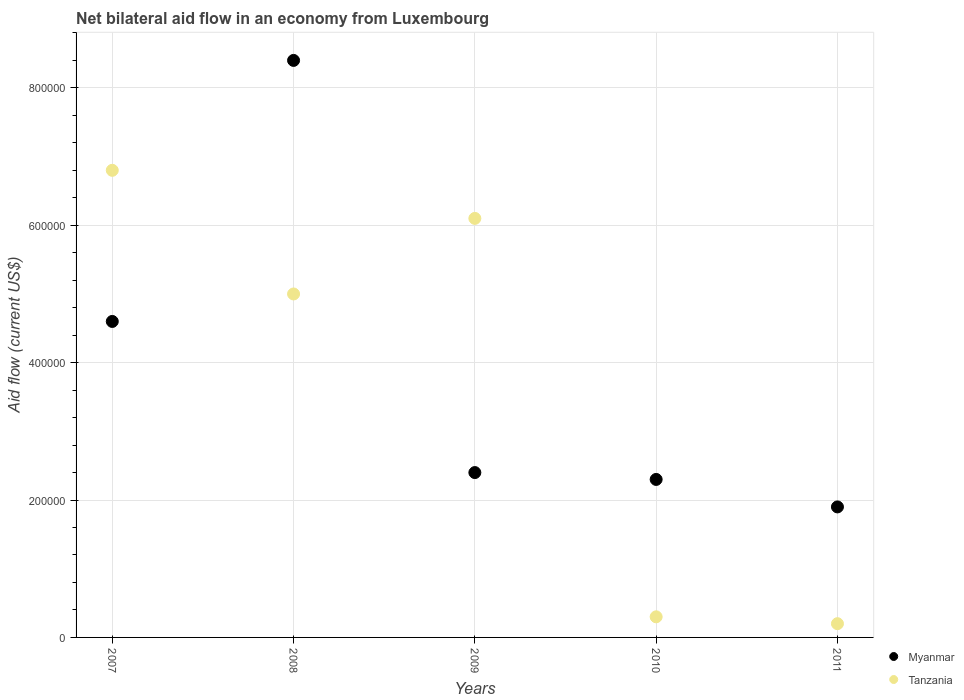How many different coloured dotlines are there?
Your answer should be very brief. 2. Is the number of dotlines equal to the number of legend labels?
Offer a very short reply. Yes. Across all years, what is the maximum net bilateral aid flow in Tanzania?
Keep it short and to the point. 6.80e+05. In which year was the net bilateral aid flow in Tanzania minimum?
Offer a very short reply. 2011. What is the total net bilateral aid flow in Tanzania in the graph?
Provide a succinct answer. 1.84e+06. What is the difference between the net bilateral aid flow in Tanzania in 2009 and that in 2010?
Ensure brevity in your answer.  5.80e+05. What is the difference between the net bilateral aid flow in Myanmar in 2007 and the net bilateral aid flow in Tanzania in 2009?
Your answer should be very brief. -1.50e+05. What is the average net bilateral aid flow in Myanmar per year?
Offer a terse response. 3.92e+05. In the year 2009, what is the difference between the net bilateral aid flow in Myanmar and net bilateral aid flow in Tanzania?
Make the answer very short. -3.70e+05. What is the ratio of the net bilateral aid flow in Myanmar in 2009 to that in 2011?
Your answer should be very brief. 1.26. Is the difference between the net bilateral aid flow in Myanmar in 2010 and 2011 greater than the difference between the net bilateral aid flow in Tanzania in 2010 and 2011?
Offer a very short reply. Yes. In how many years, is the net bilateral aid flow in Tanzania greater than the average net bilateral aid flow in Tanzania taken over all years?
Your response must be concise. 3. Is the sum of the net bilateral aid flow in Myanmar in 2008 and 2011 greater than the maximum net bilateral aid flow in Tanzania across all years?
Your answer should be compact. Yes. Is the net bilateral aid flow in Tanzania strictly less than the net bilateral aid flow in Myanmar over the years?
Offer a very short reply. No. How many years are there in the graph?
Give a very brief answer. 5. What is the difference between two consecutive major ticks on the Y-axis?
Provide a succinct answer. 2.00e+05. How are the legend labels stacked?
Your answer should be very brief. Vertical. What is the title of the graph?
Your response must be concise. Net bilateral aid flow in an economy from Luxembourg. Does "Macedonia" appear as one of the legend labels in the graph?
Your answer should be very brief. No. What is the label or title of the X-axis?
Ensure brevity in your answer.  Years. What is the label or title of the Y-axis?
Your answer should be very brief. Aid flow (current US$). What is the Aid flow (current US$) in Tanzania in 2007?
Your answer should be very brief. 6.80e+05. What is the Aid flow (current US$) of Myanmar in 2008?
Keep it short and to the point. 8.40e+05. What is the Aid flow (current US$) of Tanzania in 2008?
Your answer should be very brief. 5.00e+05. What is the Aid flow (current US$) in Tanzania in 2009?
Your answer should be compact. 6.10e+05. Across all years, what is the maximum Aid flow (current US$) in Myanmar?
Provide a succinct answer. 8.40e+05. Across all years, what is the maximum Aid flow (current US$) in Tanzania?
Ensure brevity in your answer.  6.80e+05. Across all years, what is the minimum Aid flow (current US$) of Myanmar?
Offer a terse response. 1.90e+05. What is the total Aid flow (current US$) in Myanmar in the graph?
Provide a succinct answer. 1.96e+06. What is the total Aid flow (current US$) of Tanzania in the graph?
Provide a short and direct response. 1.84e+06. What is the difference between the Aid flow (current US$) of Myanmar in 2007 and that in 2008?
Your response must be concise. -3.80e+05. What is the difference between the Aid flow (current US$) in Tanzania in 2007 and that in 2010?
Your answer should be very brief. 6.50e+05. What is the difference between the Aid flow (current US$) in Tanzania in 2007 and that in 2011?
Keep it short and to the point. 6.60e+05. What is the difference between the Aid flow (current US$) of Myanmar in 2008 and that in 2009?
Give a very brief answer. 6.00e+05. What is the difference between the Aid flow (current US$) in Myanmar in 2008 and that in 2011?
Offer a terse response. 6.50e+05. What is the difference between the Aid flow (current US$) of Tanzania in 2009 and that in 2010?
Offer a terse response. 5.80e+05. What is the difference between the Aid flow (current US$) of Myanmar in 2009 and that in 2011?
Keep it short and to the point. 5.00e+04. What is the difference between the Aid flow (current US$) of Tanzania in 2009 and that in 2011?
Offer a terse response. 5.90e+05. What is the difference between the Aid flow (current US$) of Tanzania in 2010 and that in 2011?
Your answer should be compact. 10000. What is the difference between the Aid flow (current US$) of Myanmar in 2007 and the Aid flow (current US$) of Tanzania in 2008?
Offer a terse response. -4.00e+04. What is the difference between the Aid flow (current US$) of Myanmar in 2007 and the Aid flow (current US$) of Tanzania in 2011?
Give a very brief answer. 4.40e+05. What is the difference between the Aid flow (current US$) of Myanmar in 2008 and the Aid flow (current US$) of Tanzania in 2009?
Your answer should be compact. 2.30e+05. What is the difference between the Aid flow (current US$) in Myanmar in 2008 and the Aid flow (current US$) in Tanzania in 2010?
Give a very brief answer. 8.10e+05. What is the difference between the Aid flow (current US$) of Myanmar in 2008 and the Aid flow (current US$) of Tanzania in 2011?
Provide a short and direct response. 8.20e+05. What is the difference between the Aid flow (current US$) of Myanmar in 2009 and the Aid flow (current US$) of Tanzania in 2011?
Your answer should be compact. 2.20e+05. What is the difference between the Aid flow (current US$) in Myanmar in 2010 and the Aid flow (current US$) in Tanzania in 2011?
Provide a short and direct response. 2.10e+05. What is the average Aid flow (current US$) in Myanmar per year?
Offer a terse response. 3.92e+05. What is the average Aid flow (current US$) of Tanzania per year?
Keep it short and to the point. 3.68e+05. In the year 2007, what is the difference between the Aid flow (current US$) of Myanmar and Aid flow (current US$) of Tanzania?
Your response must be concise. -2.20e+05. In the year 2008, what is the difference between the Aid flow (current US$) in Myanmar and Aid flow (current US$) in Tanzania?
Make the answer very short. 3.40e+05. In the year 2009, what is the difference between the Aid flow (current US$) in Myanmar and Aid flow (current US$) in Tanzania?
Give a very brief answer. -3.70e+05. In the year 2010, what is the difference between the Aid flow (current US$) in Myanmar and Aid flow (current US$) in Tanzania?
Your answer should be compact. 2.00e+05. What is the ratio of the Aid flow (current US$) of Myanmar in 2007 to that in 2008?
Your response must be concise. 0.55. What is the ratio of the Aid flow (current US$) in Tanzania in 2007 to that in 2008?
Your answer should be very brief. 1.36. What is the ratio of the Aid flow (current US$) in Myanmar in 2007 to that in 2009?
Make the answer very short. 1.92. What is the ratio of the Aid flow (current US$) in Tanzania in 2007 to that in 2009?
Give a very brief answer. 1.11. What is the ratio of the Aid flow (current US$) of Tanzania in 2007 to that in 2010?
Make the answer very short. 22.67. What is the ratio of the Aid flow (current US$) of Myanmar in 2007 to that in 2011?
Your answer should be compact. 2.42. What is the ratio of the Aid flow (current US$) of Tanzania in 2008 to that in 2009?
Provide a succinct answer. 0.82. What is the ratio of the Aid flow (current US$) of Myanmar in 2008 to that in 2010?
Give a very brief answer. 3.65. What is the ratio of the Aid flow (current US$) of Tanzania in 2008 to that in 2010?
Provide a short and direct response. 16.67. What is the ratio of the Aid flow (current US$) in Myanmar in 2008 to that in 2011?
Give a very brief answer. 4.42. What is the ratio of the Aid flow (current US$) of Myanmar in 2009 to that in 2010?
Keep it short and to the point. 1.04. What is the ratio of the Aid flow (current US$) of Tanzania in 2009 to that in 2010?
Offer a terse response. 20.33. What is the ratio of the Aid flow (current US$) of Myanmar in 2009 to that in 2011?
Give a very brief answer. 1.26. What is the ratio of the Aid flow (current US$) of Tanzania in 2009 to that in 2011?
Provide a succinct answer. 30.5. What is the ratio of the Aid flow (current US$) in Myanmar in 2010 to that in 2011?
Keep it short and to the point. 1.21. What is the difference between the highest and the second highest Aid flow (current US$) in Tanzania?
Your response must be concise. 7.00e+04. What is the difference between the highest and the lowest Aid flow (current US$) in Myanmar?
Ensure brevity in your answer.  6.50e+05. 